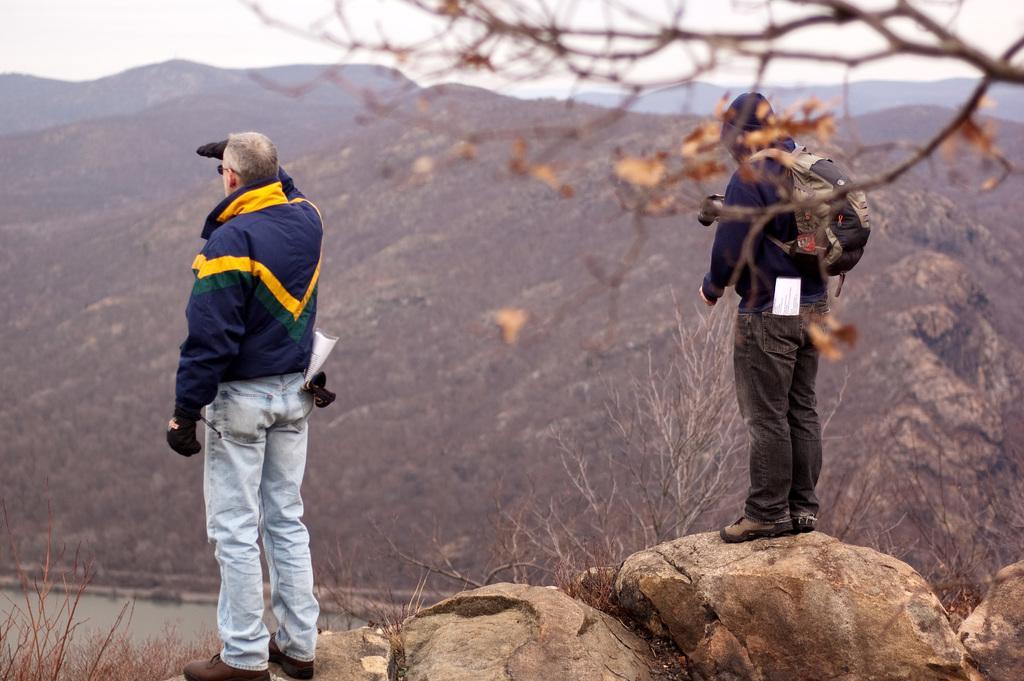Can you describe this image briefly? In this image i can see 2 persons standing on rocks. In the background i can see mountains, trees and the sky. 